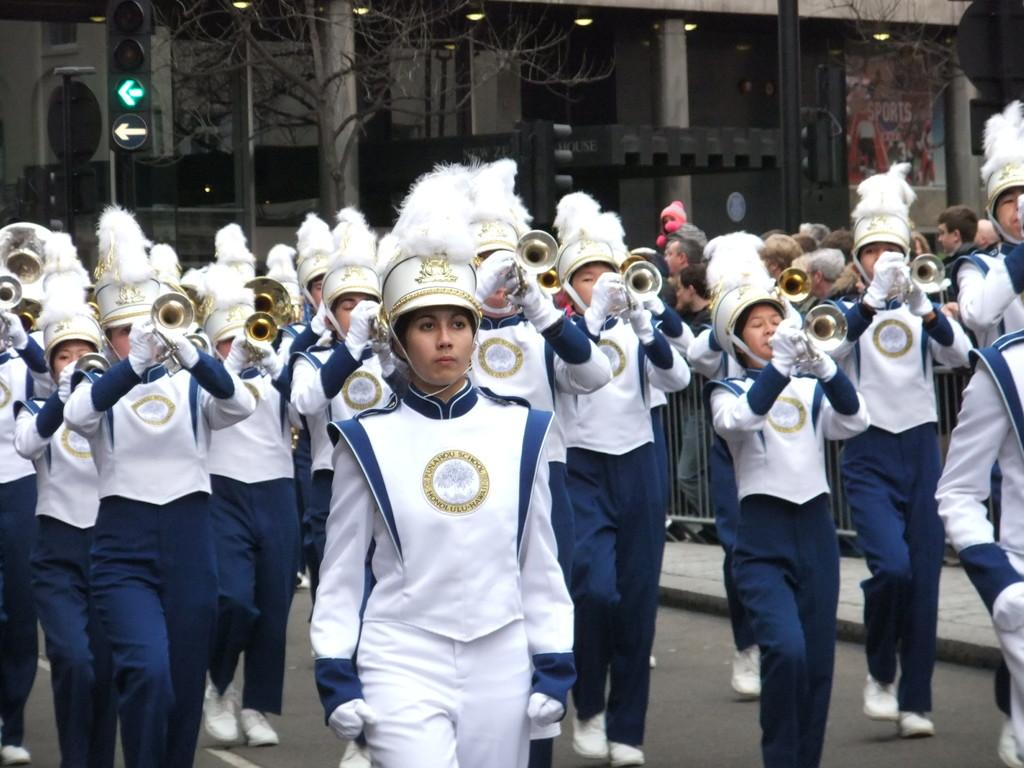What are the women in the image doing? The women in the image are playing musical instruments. What are the women wearing on their heads? The women are wearing helmets. What can be seen in the background of the image? There are buildings and trees in the background of the image. What type of silverware is the dad using in the image? There is no dad or silverware present in the image. 